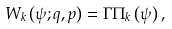Convert formula to latex. <formula><loc_0><loc_0><loc_500><loc_500>W _ { k } \left ( \psi ; q , p \right ) = \Gamma \Pi _ { k } \left ( \psi \right ) ,</formula> 